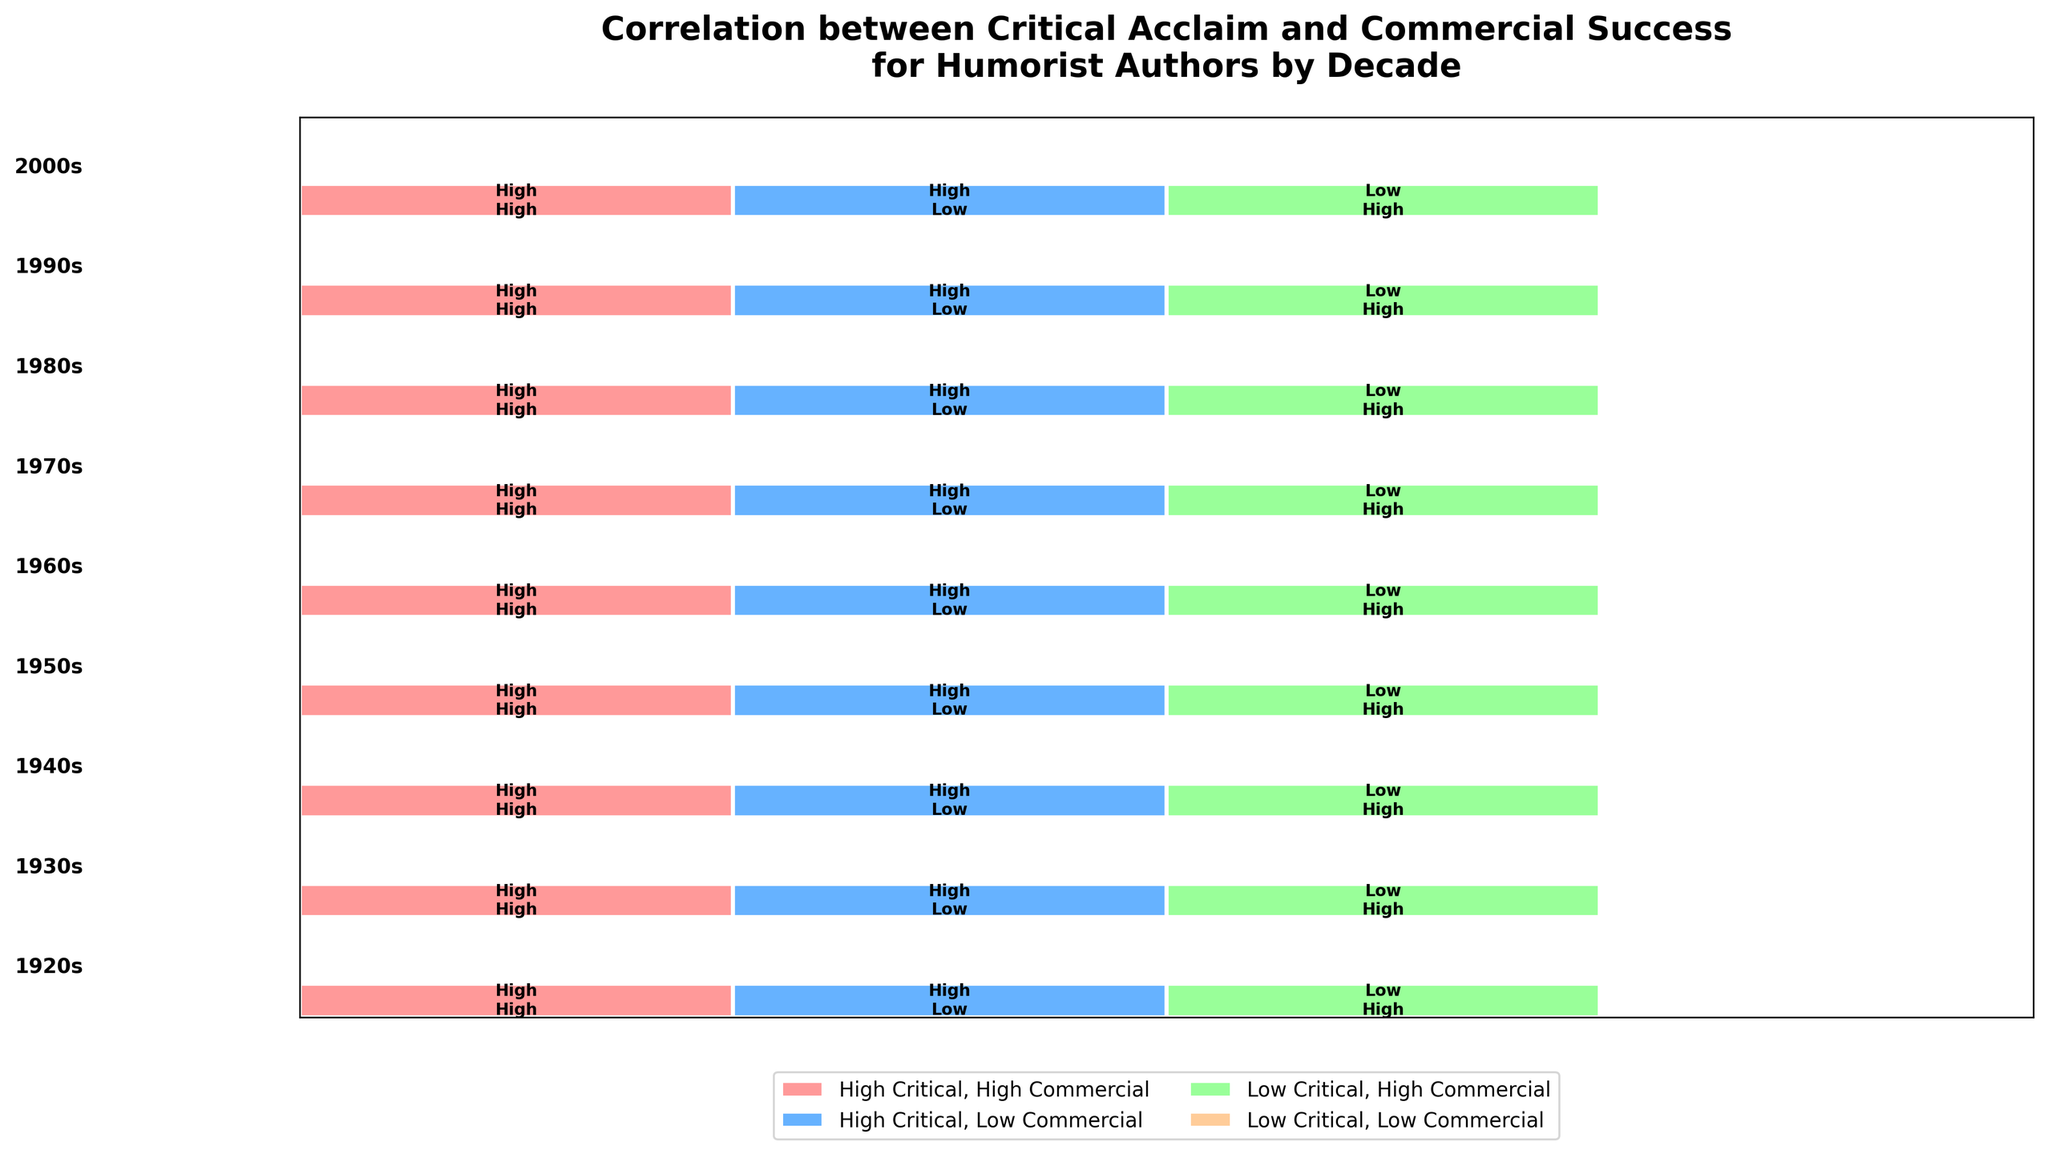What is the title of the plot? The title is usually located at the top of the figure. In this plot, it is "Correlation between Critical Acclaim and Commercial Success for Humorist Authors by Decade".
Answer: Correlation between Critical Acclaim and Commercial Success for Humorist Authors by Decade Which decade shows a higher proportion of authors with both high critical acclaim and high commercial success? To determine this, we need to compare the rectangles labeled "High, High" across all decades. The decade with the tallest rectangle in this category has the highest proportion.
Answer: 1990s How many different categories of critical acclaim and commercial success combinations are there? Examining the legend and the labels within the rectangles, we see four combinations: "High Critical, High Commercial", "High Critical, Low Commercial", "Low Critical, High Commercial", and "Low Critical, Low Commercial".
Answer: Four In which decade did all authors either have high critical acclaim or high commercial success but not both? Identify the decade where no authors fall into the "High Critical, High Commercial" or "Low Critical, Low Commercial" categories.
Answer: None What decade has the lowest proportion of authors with low critical acclaim and low commercial success? By visually comparing the height of the rectangles labeled "Low, Low" across all decades, determine which decade has the smallest or almost non-existent rectangle in that category.
Answer: All decades In terms of critical acclaim alone, did authors from the 1980s have a higher proportion of high or low acclaim? Summing the proportions of "High, High" and "High, Low" and comparing to the sum of "Low, High" and "Low, Low" for the 1980s will indicate this. The combined height of 'High' categories in the 1980s is higher.
Answer: High acclaim Compare the proportion of high critical acclaim and low commercial success between the 1920s and the 1980s. Which decade had a higher proportion? Look at the height of the "High, Low" rectangles for the 1920s and the 1980s. The decade with the taller rectangle has a higher proportion.
Answer: 1920s Which combination category does not have a representative in the 1940s? Reviewing the 1940s section, note which of the four categories (High, High; High, Low; Low, High; Low, Low) has no rectangle or is not labeled.
Answer: Low, Low 